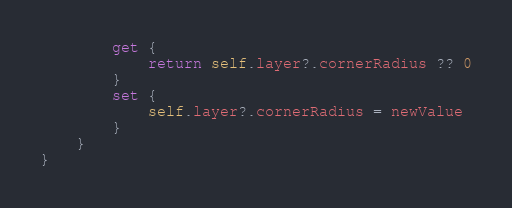Convert code to text. <code><loc_0><loc_0><loc_500><loc_500><_Swift_>        get {
            return self.layer?.cornerRadius ?? 0
        }
        set {
            self.layer?.cornerRadius = newValue
        }
    }
}
</code> 